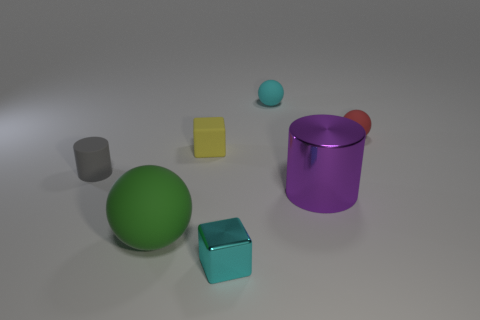Add 1 big purple things. How many objects exist? 8 Subtract all cylinders. How many objects are left? 5 Add 7 purple shiny things. How many purple shiny things exist? 8 Subtract 1 yellow cubes. How many objects are left? 6 Subtract all small green balls. Subtract all cubes. How many objects are left? 5 Add 4 small cyan shiny objects. How many small cyan shiny objects are left? 5 